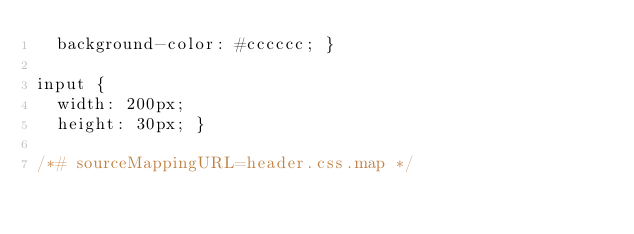<code> <loc_0><loc_0><loc_500><loc_500><_CSS_>  background-color: #cccccc; }

input {
  width: 200px;
  height: 30px; }

/*# sourceMappingURL=header.css.map */
</code> 